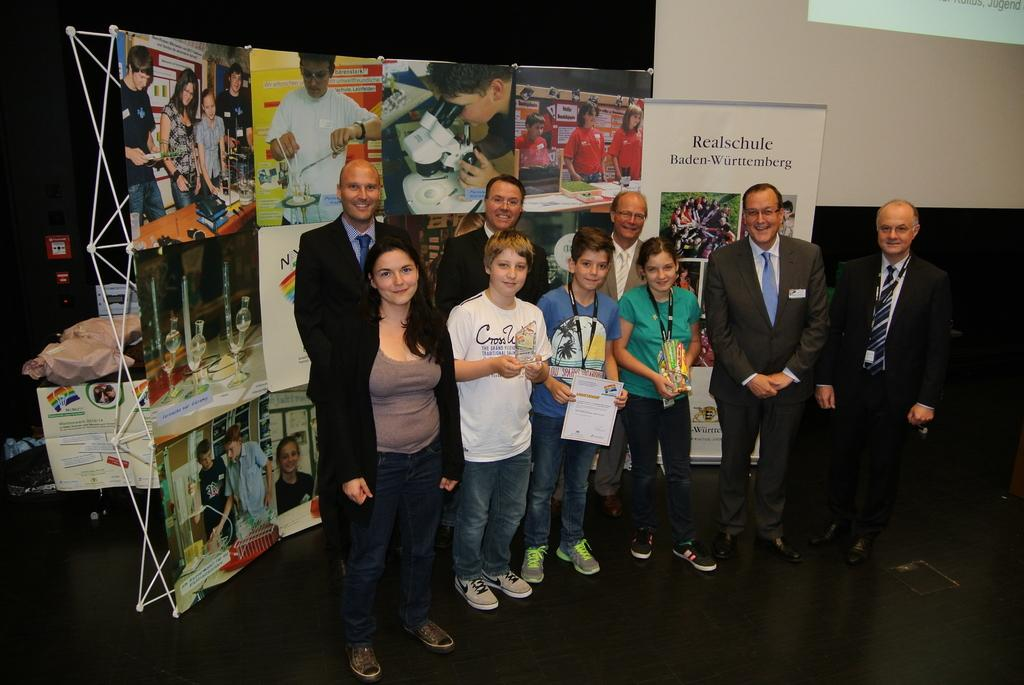What can be seen in the image? There are people standing in the image. What else is present in the image besides the people? There are banners with text and images in the image. What type of oatmeal is being served at the event depicted in the image? There is no mention of oatmeal or any event in the image; it only shows people and banners. 